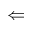Convert formula to latex. <formula><loc_0><loc_0><loc_500><loc_500>\Leftarrow</formula> 